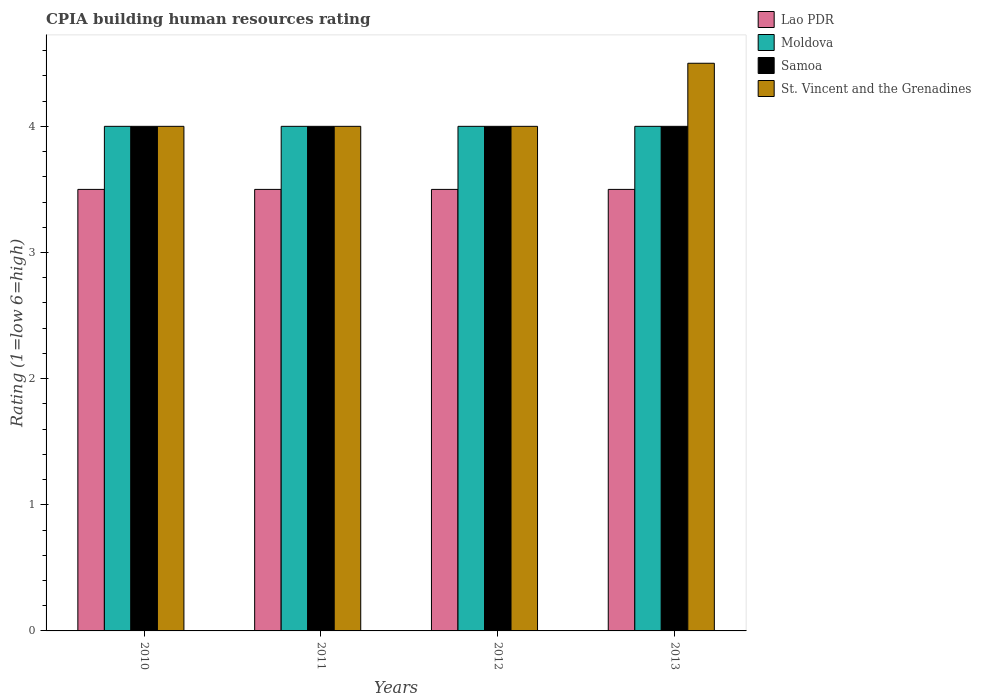How many different coloured bars are there?
Provide a succinct answer. 4. How many groups of bars are there?
Make the answer very short. 4. Are the number of bars per tick equal to the number of legend labels?
Provide a succinct answer. Yes. What is the label of the 2nd group of bars from the left?
Give a very brief answer. 2011. In how many cases, is the number of bars for a given year not equal to the number of legend labels?
Your answer should be compact. 0. What is the CPIA rating in Samoa in 2011?
Your response must be concise. 4. Across all years, what is the maximum CPIA rating in Samoa?
Provide a succinct answer. 4. Across all years, what is the minimum CPIA rating in Samoa?
Provide a short and direct response. 4. In which year was the CPIA rating in St. Vincent and the Grenadines maximum?
Provide a short and direct response. 2013. In which year was the CPIA rating in Moldova minimum?
Offer a terse response. 2010. What is the total CPIA rating in Samoa in the graph?
Offer a terse response. 16. What is the average CPIA rating in Lao PDR per year?
Offer a terse response. 3.5. In the year 2012, what is the difference between the CPIA rating in St. Vincent and the Grenadines and CPIA rating in Moldova?
Offer a terse response. 0. Is the CPIA rating in Lao PDR in 2011 less than that in 2013?
Keep it short and to the point. No. What is the difference between the highest and the lowest CPIA rating in St. Vincent and the Grenadines?
Provide a succinct answer. 0.5. In how many years, is the CPIA rating in Samoa greater than the average CPIA rating in Samoa taken over all years?
Provide a short and direct response. 0. Is it the case that in every year, the sum of the CPIA rating in Moldova and CPIA rating in Samoa is greater than the sum of CPIA rating in St. Vincent and the Grenadines and CPIA rating in Lao PDR?
Offer a terse response. No. What does the 2nd bar from the left in 2010 represents?
Make the answer very short. Moldova. What does the 3rd bar from the right in 2012 represents?
Make the answer very short. Moldova. How many bars are there?
Offer a terse response. 16. How many years are there in the graph?
Provide a short and direct response. 4. What is the difference between two consecutive major ticks on the Y-axis?
Offer a terse response. 1. Does the graph contain any zero values?
Keep it short and to the point. No. Does the graph contain grids?
Your answer should be compact. No. What is the title of the graph?
Ensure brevity in your answer.  CPIA building human resources rating. Does "Isle of Man" appear as one of the legend labels in the graph?
Your answer should be compact. No. What is the Rating (1=low 6=high) of Moldova in 2010?
Provide a succinct answer. 4. What is the Rating (1=low 6=high) of Lao PDR in 2011?
Your answer should be compact. 3.5. What is the Rating (1=low 6=high) in Moldova in 2011?
Your answer should be very brief. 4. What is the Rating (1=low 6=high) of St. Vincent and the Grenadines in 2011?
Your response must be concise. 4. What is the Rating (1=low 6=high) in St. Vincent and the Grenadines in 2012?
Provide a succinct answer. 4. What is the Rating (1=low 6=high) of Lao PDR in 2013?
Give a very brief answer. 3.5. What is the Rating (1=low 6=high) in Samoa in 2013?
Ensure brevity in your answer.  4. What is the Rating (1=low 6=high) of St. Vincent and the Grenadines in 2013?
Provide a succinct answer. 4.5. Across all years, what is the maximum Rating (1=low 6=high) of Lao PDR?
Give a very brief answer. 3.5. Across all years, what is the maximum Rating (1=low 6=high) of Moldova?
Provide a short and direct response. 4. What is the total Rating (1=low 6=high) in Lao PDR in the graph?
Your response must be concise. 14. What is the total Rating (1=low 6=high) of Samoa in the graph?
Offer a terse response. 16. What is the total Rating (1=low 6=high) of St. Vincent and the Grenadines in the graph?
Ensure brevity in your answer.  16.5. What is the difference between the Rating (1=low 6=high) of Lao PDR in 2010 and that in 2011?
Your answer should be compact. 0. What is the difference between the Rating (1=low 6=high) of Moldova in 2010 and that in 2011?
Offer a terse response. 0. What is the difference between the Rating (1=low 6=high) of St. Vincent and the Grenadines in 2010 and that in 2011?
Offer a very short reply. 0. What is the difference between the Rating (1=low 6=high) in Lao PDR in 2010 and that in 2012?
Offer a terse response. 0. What is the difference between the Rating (1=low 6=high) in Moldova in 2010 and that in 2012?
Ensure brevity in your answer.  0. What is the difference between the Rating (1=low 6=high) of St. Vincent and the Grenadines in 2010 and that in 2012?
Make the answer very short. 0. What is the difference between the Rating (1=low 6=high) of Lao PDR in 2010 and that in 2013?
Offer a very short reply. 0. What is the difference between the Rating (1=low 6=high) of Moldova in 2010 and that in 2013?
Your answer should be compact. 0. What is the difference between the Rating (1=low 6=high) in St. Vincent and the Grenadines in 2010 and that in 2013?
Offer a terse response. -0.5. What is the difference between the Rating (1=low 6=high) in Samoa in 2011 and that in 2012?
Give a very brief answer. 0. What is the difference between the Rating (1=low 6=high) in Moldova in 2012 and that in 2013?
Ensure brevity in your answer.  0. What is the difference between the Rating (1=low 6=high) in Moldova in 2010 and the Rating (1=low 6=high) in St. Vincent and the Grenadines in 2011?
Give a very brief answer. 0. What is the difference between the Rating (1=low 6=high) of Samoa in 2010 and the Rating (1=low 6=high) of St. Vincent and the Grenadines in 2011?
Provide a short and direct response. 0. What is the difference between the Rating (1=low 6=high) in Lao PDR in 2010 and the Rating (1=low 6=high) in Moldova in 2012?
Keep it short and to the point. -0.5. What is the difference between the Rating (1=low 6=high) in Moldova in 2010 and the Rating (1=low 6=high) in St. Vincent and the Grenadines in 2012?
Your answer should be very brief. 0. What is the difference between the Rating (1=low 6=high) of Lao PDR in 2010 and the Rating (1=low 6=high) of Moldova in 2013?
Provide a succinct answer. -0.5. What is the difference between the Rating (1=low 6=high) in Lao PDR in 2010 and the Rating (1=low 6=high) in Samoa in 2013?
Give a very brief answer. -0.5. What is the difference between the Rating (1=low 6=high) of Samoa in 2010 and the Rating (1=low 6=high) of St. Vincent and the Grenadines in 2013?
Provide a short and direct response. -0.5. What is the difference between the Rating (1=low 6=high) of Lao PDR in 2011 and the Rating (1=low 6=high) of Samoa in 2012?
Make the answer very short. -0.5. What is the difference between the Rating (1=low 6=high) in Lao PDR in 2011 and the Rating (1=low 6=high) in St. Vincent and the Grenadines in 2012?
Make the answer very short. -0.5. What is the difference between the Rating (1=low 6=high) in Moldova in 2011 and the Rating (1=low 6=high) in Samoa in 2012?
Your response must be concise. 0. What is the difference between the Rating (1=low 6=high) in Samoa in 2011 and the Rating (1=low 6=high) in St. Vincent and the Grenadines in 2012?
Keep it short and to the point. 0. What is the difference between the Rating (1=low 6=high) in Lao PDR in 2011 and the Rating (1=low 6=high) in St. Vincent and the Grenadines in 2013?
Ensure brevity in your answer.  -1. What is the difference between the Rating (1=low 6=high) in Moldova in 2011 and the Rating (1=low 6=high) in St. Vincent and the Grenadines in 2013?
Make the answer very short. -0.5. What is the difference between the Rating (1=low 6=high) of Samoa in 2011 and the Rating (1=low 6=high) of St. Vincent and the Grenadines in 2013?
Keep it short and to the point. -0.5. What is the difference between the Rating (1=low 6=high) of Lao PDR in 2012 and the Rating (1=low 6=high) of Moldova in 2013?
Your response must be concise. -0.5. What is the difference between the Rating (1=low 6=high) of Lao PDR in 2012 and the Rating (1=low 6=high) of St. Vincent and the Grenadines in 2013?
Your answer should be compact. -1. What is the difference between the Rating (1=low 6=high) in Moldova in 2012 and the Rating (1=low 6=high) in Samoa in 2013?
Offer a terse response. 0. What is the difference between the Rating (1=low 6=high) in Moldova in 2012 and the Rating (1=low 6=high) in St. Vincent and the Grenadines in 2013?
Your response must be concise. -0.5. What is the difference between the Rating (1=low 6=high) in Samoa in 2012 and the Rating (1=low 6=high) in St. Vincent and the Grenadines in 2013?
Ensure brevity in your answer.  -0.5. What is the average Rating (1=low 6=high) in Moldova per year?
Make the answer very short. 4. What is the average Rating (1=low 6=high) in St. Vincent and the Grenadines per year?
Give a very brief answer. 4.12. In the year 2010, what is the difference between the Rating (1=low 6=high) in Samoa and Rating (1=low 6=high) in St. Vincent and the Grenadines?
Your response must be concise. 0. In the year 2011, what is the difference between the Rating (1=low 6=high) of Lao PDR and Rating (1=low 6=high) of Moldova?
Keep it short and to the point. -0.5. In the year 2011, what is the difference between the Rating (1=low 6=high) of Lao PDR and Rating (1=low 6=high) of Samoa?
Offer a very short reply. -0.5. In the year 2011, what is the difference between the Rating (1=low 6=high) of Lao PDR and Rating (1=low 6=high) of St. Vincent and the Grenadines?
Your answer should be very brief. -0.5. In the year 2011, what is the difference between the Rating (1=low 6=high) of Moldova and Rating (1=low 6=high) of Samoa?
Offer a terse response. 0. In the year 2011, what is the difference between the Rating (1=low 6=high) of Moldova and Rating (1=low 6=high) of St. Vincent and the Grenadines?
Your answer should be very brief. 0. In the year 2011, what is the difference between the Rating (1=low 6=high) of Samoa and Rating (1=low 6=high) of St. Vincent and the Grenadines?
Ensure brevity in your answer.  0. In the year 2012, what is the difference between the Rating (1=low 6=high) in Lao PDR and Rating (1=low 6=high) in Moldova?
Give a very brief answer. -0.5. In the year 2012, what is the difference between the Rating (1=low 6=high) in Lao PDR and Rating (1=low 6=high) in Samoa?
Your answer should be compact. -0.5. In the year 2012, what is the difference between the Rating (1=low 6=high) of Lao PDR and Rating (1=low 6=high) of St. Vincent and the Grenadines?
Provide a succinct answer. -0.5. In the year 2012, what is the difference between the Rating (1=low 6=high) in Moldova and Rating (1=low 6=high) in Samoa?
Ensure brevity in your answer.  0. In the year 2012, what is the difference between the Rating (1=low 6=high) in Samoa and Rating (1=low 6=high) in St. Vincent and the Grenadines?
Keep it short and to the point. 0. In the year 2013, what is the difference between the Rating (1=low 6=high) of Lao PDR and Rating (1=low 6=high) of Samoa?
Your response must be concise. -0.5. In the year 2013, what is the difference between the Rating (1=low 6=high) in Lao PDR and Rating (1=low 6=high) in St. Vincent and the Grenadines?
Your answer should be compact. -1. In the year 2013, what is the difference between the Rating (1=low 6=high) of Moldova and Rating (1=low 6=high) of St. Vincent and the Grenadines?
Offer a very short reply. -0.5. What is the ratio of the Rating (1=low 6=high) of Lao PDR in 2010 to that in 2011?
Your answer should be compact. 1. What is the ratio of the Rating (1=low 6=high) in Lao PDR in 2010 to that in 2012?
Make the answer very short. 1. What is the ratio of the Rating (1=low 6=high) of St. Vincent and the Grenadines in 2010 to that in 2012?
Offer a terse response. 1. What is the ratio of the Rating (1=low 6=high) in Moldova in 2010 to that in 2013?
Offer a terse response. 1. What is the ratio of the Rating (1=low 6=high) in Samoa in 2010 to that in 2013?
Keep it short and to the point. 1. What is the ratio of the Rating (1=low 6=high) of St. Vincent and the Grenadines in 2010 to that in 2013?
Offer a terse response. 0.89. What is the ratio of the Rating (1=low 6=high) of Samoa in 2011 to that in 2012?
Ensure brevity in your answer.  1. What is the ratio of the Rating (1=low 6=high) of St. Vincent and the Grenadines in 2011 to that in 2012?
Keep it short and to the point. 1. What is the ratio of the Rating (1=low 6=high) of Lao PDR in 2011 to that in 2013?
Offer a terse response. 1. What is the ratio of the Rating (1=low 6=high) in Moldova in 2011 to that in 2013?
Provide a succinct answer. 1. What is the ratio of the Rating (1=low 6=high) in Moldova in 2012 to that in 2013?
Offer a terse response. 1. What is the ratio of the Rating (1=low 6=high) in Samoa in 2012 to that in 2013?
Offer a very short reply. 1. What is the difference between the highest and the second highest Rating (1=low 6=high) in Moldova?
Give a very brief answer. 0. What is the difference between the highest and the second highest Rating (1=low 6=high) of St. Vincent and the Grenadines?
Ensure brevity in your answer.  0.5. What is the difference between the highest and the lowest Rating (1=low 6=high) of Lao PDR?
Ensure brevity in your answer.  0. What is the difference between the highest and the lowest Rating (1=low 6=high) of Moldova?
Your answer should be very brief. 0. What is the difference between the highest and the lowest Rating (1=low 6=high) of Samoa?
Give a very brief answer. 0. What is the difference between the highest and the lowest Rating (1=low 6=high) of St. Vincent and the Grenadines?
Provide a short and direct response. 0.5. 